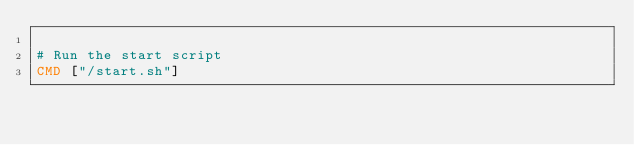Convert code to text. <code><loc_0><loc_0><loc_500><loc_500><_Dockerfile_>
# Run the start script
CMD ["/start.sh"]
</code> 